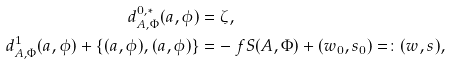<formula> <loc_0><loc_0><loc_500><loc_500>d _ { A , \Phi } ^ { 0 , * } ( a , \phi ) & = \zeta , \\ d _ { A , \Phi } ^ { 1 } ( a , \phi ) + \{ ( a , \phi ) , ( a , \phi ) \} & = - \ f S ( A , \Phi ) + ( w _ { 0 } , s _ { 0 } ) = \colon ( w , s ) ,</formula> 